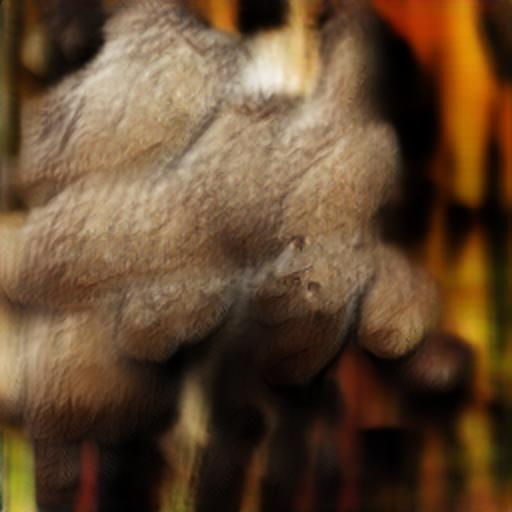Does this image have a good color balance? The image appears to have an imbalance in color with a dominant yellow-brown tint overshadowing other colors, which may not be considered ideal for good color balance. It's important to note, however, that the overall aesthetic and whether the color balance is pleasing can be subjective and dependent on the context in which the image is being used. 